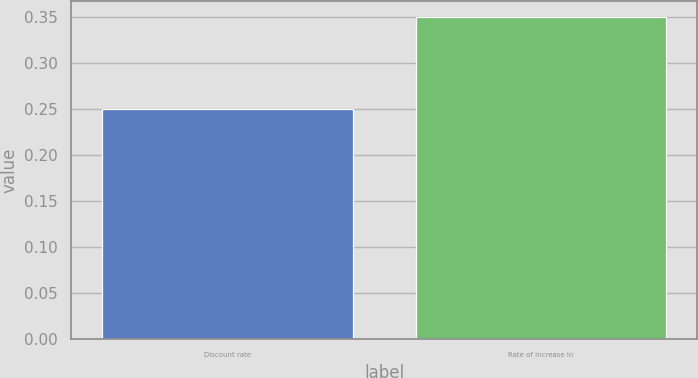Convert chart to OTSL. <chart><loc_0><loc_0><loc_500><loc_500><bar_chart><fcel>Discount rate<fcel>Rate of increase in<nl><fcel>0.25<fcel>0.35<nl></chart> 